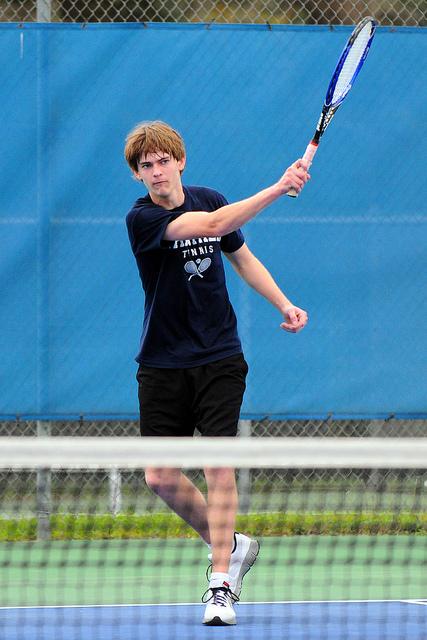What color is the man's shirt?
Short answer required. Black. What is he playing?
Keep it brief. Tennis. What college does the man play tennis for?
Quick response, please. Harvard. Is he left-handed?
Answer briefly. No. 